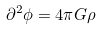Convert formula to latex. <formula><loc_0><loc_0><loc_500><loc_500>\partial ^ { 2 } \phi = 4 \pi G \rho</formula> 